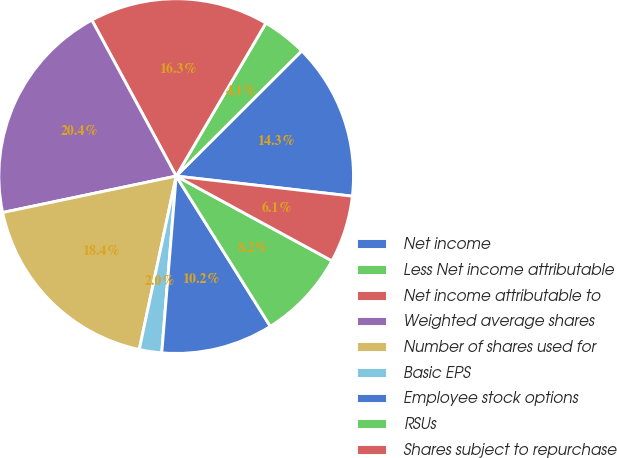Convert chart to OTSL. <chart><loc_0><loc_0><loc_500><loc_500><pie_chart><fcel>Net income<fcel>Less Net income attributable<fcel>Net income attributable to<fcel>Weighted average shares<fcel>Number of shares used for<fcel>Basic EPS<fcel>Employee stock options<fcel>RSUs<fcel>Shares subject to repurchase<nl><fcel>14.28%<fcel>4.08%<fcel>16.32%<fcel>20.4%<fcel>18.36%<fcel>2.04%<fcel>10.2%<fcel>8.16%<fcel>6.12%<nl></chart> 